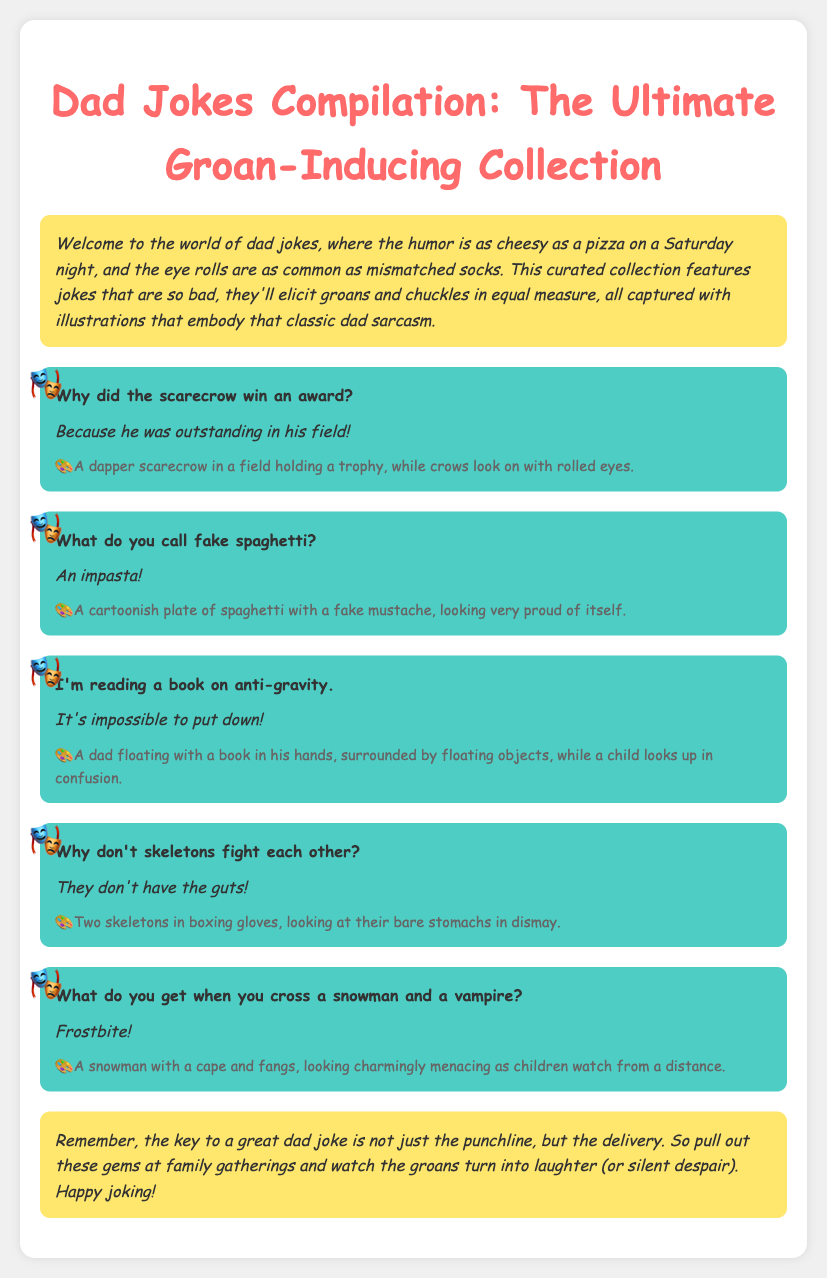What is the title of the document? The title is presented at the top of the document.
Answer: Dad Jokes Compilation: The Ultimate Groan-Inducing Collection How many jokes are featured in the document? The document lists five jokes in total.
Answer: Five What award did the scarecrow win? The setup of the first joke indicates he won an award.
Answer: Outstanding in his field What do you call fake spaghetti? The punchline of the second joke provides the answer.
Answer: An impasta What is the illustration of the snowman and vampire called? The punchline of the joke describes its humorous name.
Answer: Frostbite What is the color of the joke background? The document describes the style attributes for the joke section.
Answer: Light blue What do skeletons lack according to the joke? The punchline of the joke mentions a missing quality.
Answer: Guts What humorous theme connects all the jokes? The introduction summarizes the overall tone of the jokes included.
Answer: Sarcasm 